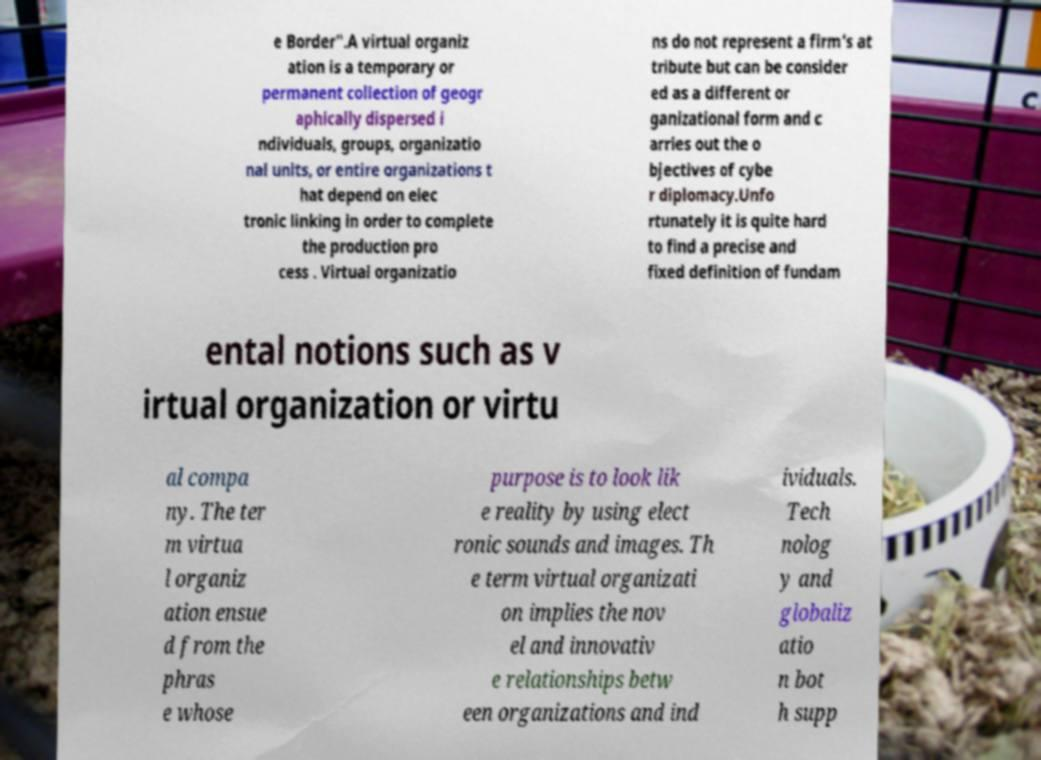For documentation purposes, I need the text within this image transcribed. Could you provide that? e Border".A virtual organiz ation is a temporary or permanent collection of geogr aphically dispersed i ndividuals, groups, organizatio nal units, or entire organizations t hat depend on elec tronic linking in order to complete the production pro cess . Virtual organizatio ns do not represent a firm’s at tribute but can be consider ed as a different or ganizational form and c arries out the o bjectives of cybe r diplomacy.Unfo rtunately it is quite hard to find a precise and fixed definition of fundam ental notions such as v irtual organization or virtu al compa ny. The ter m virtua l organiz ation ensue d from the phras e whose purpose is to look lik e reality by using elect ronic sounds and images. Th e term virtual organizati on implies the nov el and innovativ e relationships betw een organizations and ind ividuals. Tech nolog y and globaliz atio n bot h supp 